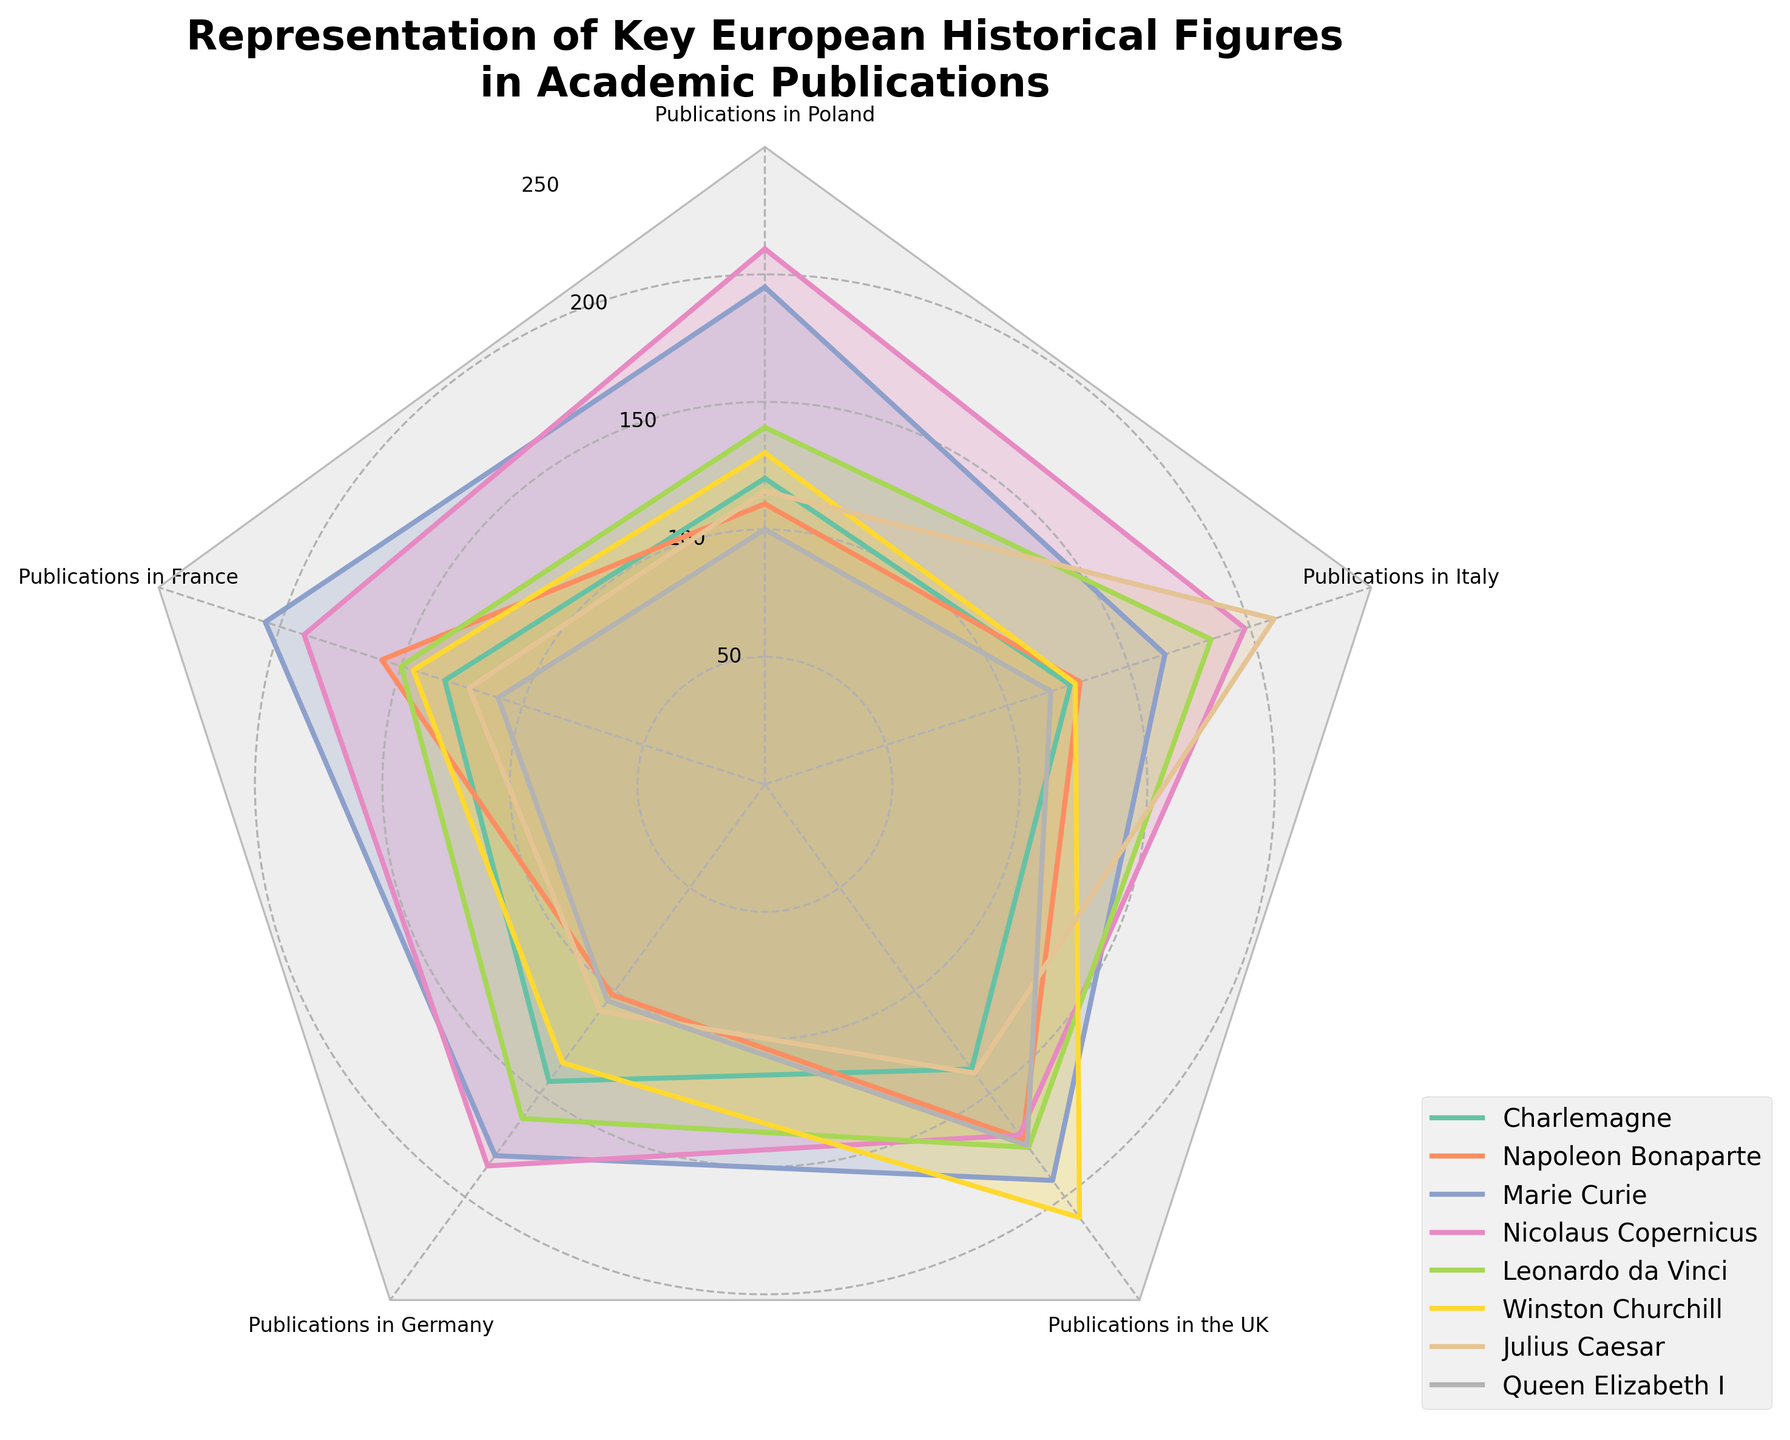What's the title of the radar chart? The title is usually located at the top of the chart. It provides context and describes what the figure represents.
Answer: Representation of Key European Historical Figures in Academic Publications Which historical figure has the highest number of publications in Poland? Look at the radar chart and identify the vertex labeled "Publications in Poland." Then, find the line that reaches the farthest point from the center on that axis and note which historical figure it represents.
Answer: Nicolaus Copernicus How many publications are there in total for Marie Curie across all the countries represented? Sum the publication numbers for Marie Curie in each country: Poland (195), France (206), Germany (180), UK (192), and Italy (165). So, 195 + 206 + 180 + 192 + 165 = 938.
Answer: 938 Who has more publications in France: Napoleon Bonaparte or Charlemagne? Look at the radar chart for the vertex labeled "Publications in France." Compare the distances for Napoleon Bonaparte and Charlemagne.
Answer: Napoleon Bonaparte What is the average number of publications for Julius Caesar, Queen Elizabeth I, and Leonardo da Vinci in Italy? Sum the publication numbers for each figure in Italy (Julius Caesar (210), Queen Elizabeth I (118), Leonardo da Vinci (184)). Then divide by the number of figures: (210 + 118 + 184) / 3 = 512 / 3.
Answer: 170.67 Which historical figure has the most balanced distribution of publications across the five countries? Find the historical figure whose radar chart shape appears most like a regular polygon (i.e., each vertex point is roughly equidistant from the center).
Answer: Marie Curie Is there any historical figure with an equal number of publications in any two countries? Check to see if any figure's radar line intersects the same distance from the center on two different axes.
Answer: No Compare the publication numbers between Nicolaus Copernicus in Germany and Winston Churchill in the UK. Who is more frequently represented? Look at the radar chart vertices for Nicolaus Copernicus in Germany and Winston Churchill in the UK and compare their distances from the center.
Answer: Winston Churchill How does the number of publications for Leonardo da Vinci in the UK compare to the number of publications for Queen Elizabeth I in France? Look at the each respective axis (Leonardo da Vinci in the UK and Queen Elizabeth I in France) and compare the distances from the center.
Answer: Leonardo da Vinci has more Which country has the highest number of publications for historical figures overall, and who is the leading figure there? Examine the overall extent of the vertices for each country and identify the widest spread. Then, find the vertex reaching the farthest from the center within that country.
Answer: Poland; Nicolaus Copernicus 